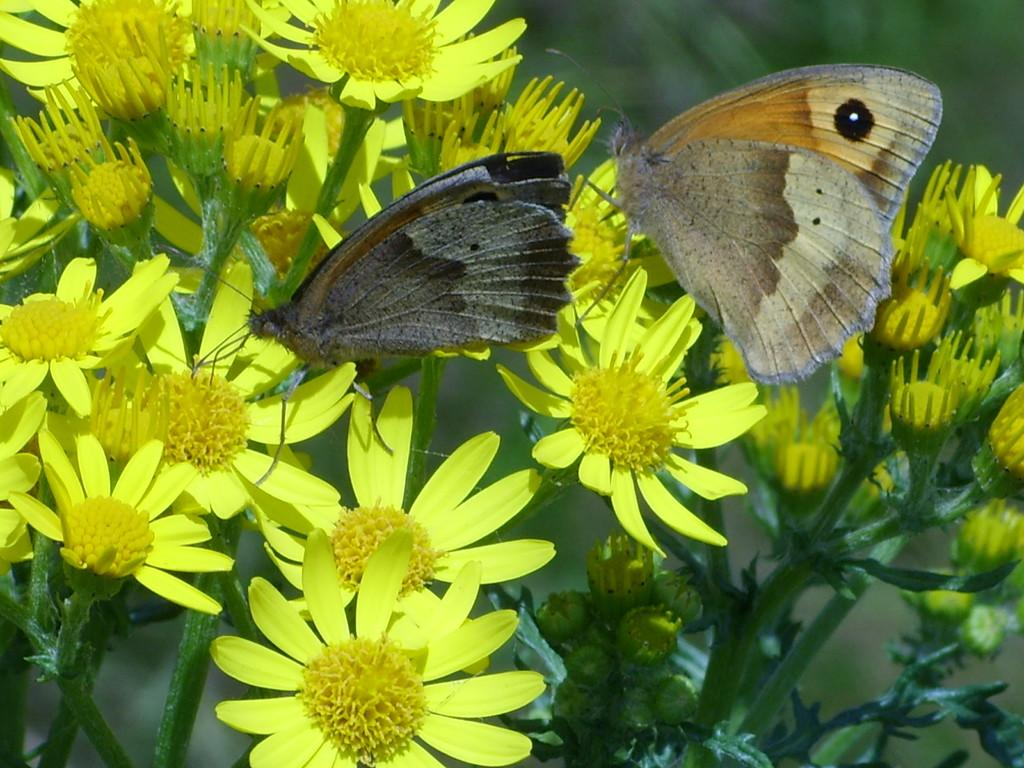What is the main subject of the image? The main subject of the image is a bunch of flowers. What is present on the flowers in the image? Butterflies are sitting on the flowers in the image. What type of nail is being hammered into the mountain in the image? There is no nail or mountain present in the image; it features a bunch of flowers with butterflies sitting on them. 